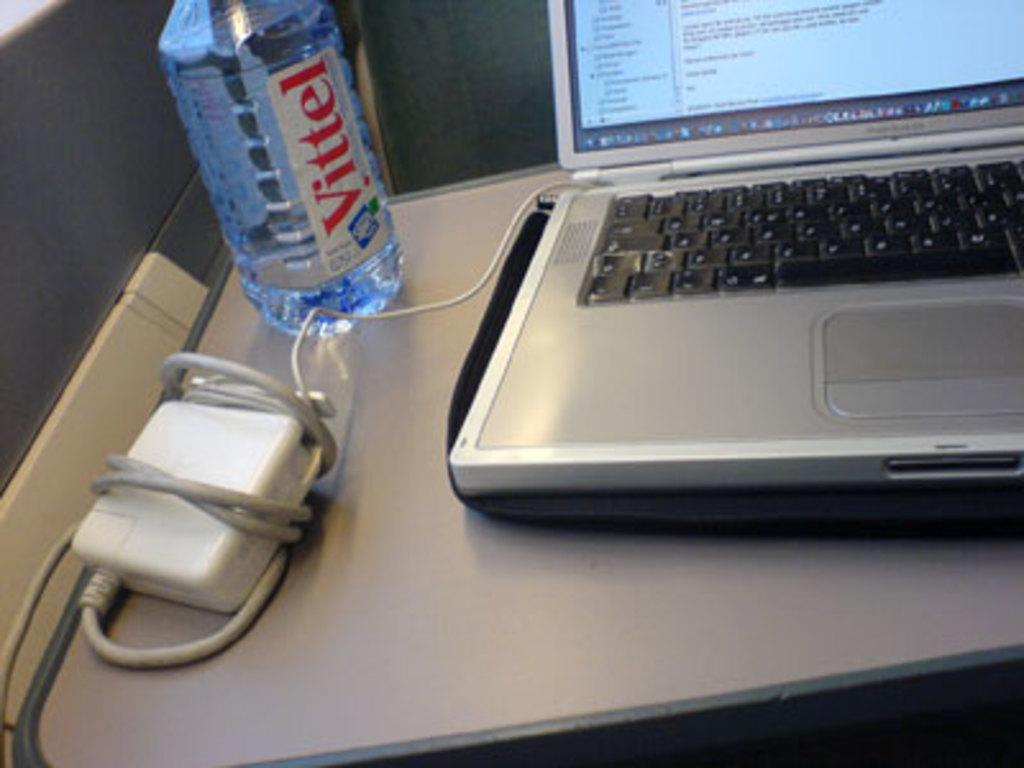<image>
Provide a brief description of the given image. Water bottle of Vitel next to a laptop on a table. 